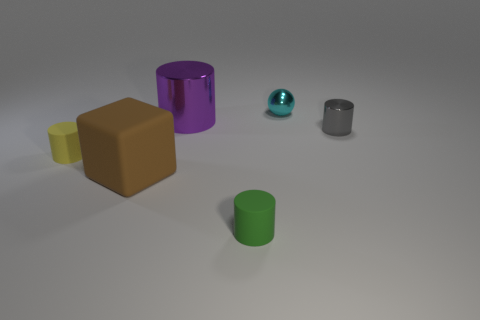Add 3 big shiny cylinders. How many objects exist? 9 Subtract all blocks. How many objects are left? 5 Subtract all yellow shiny spheres. Subtract all small yellow things. How many objects are left? 5 Add 5 cubes. How many cubes are left? 6 Add 1 small brown blocks. How many small brown blocks exist? 1 Subtract 0 cyan cylinders. How many objects are left? 6 